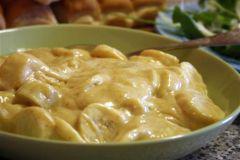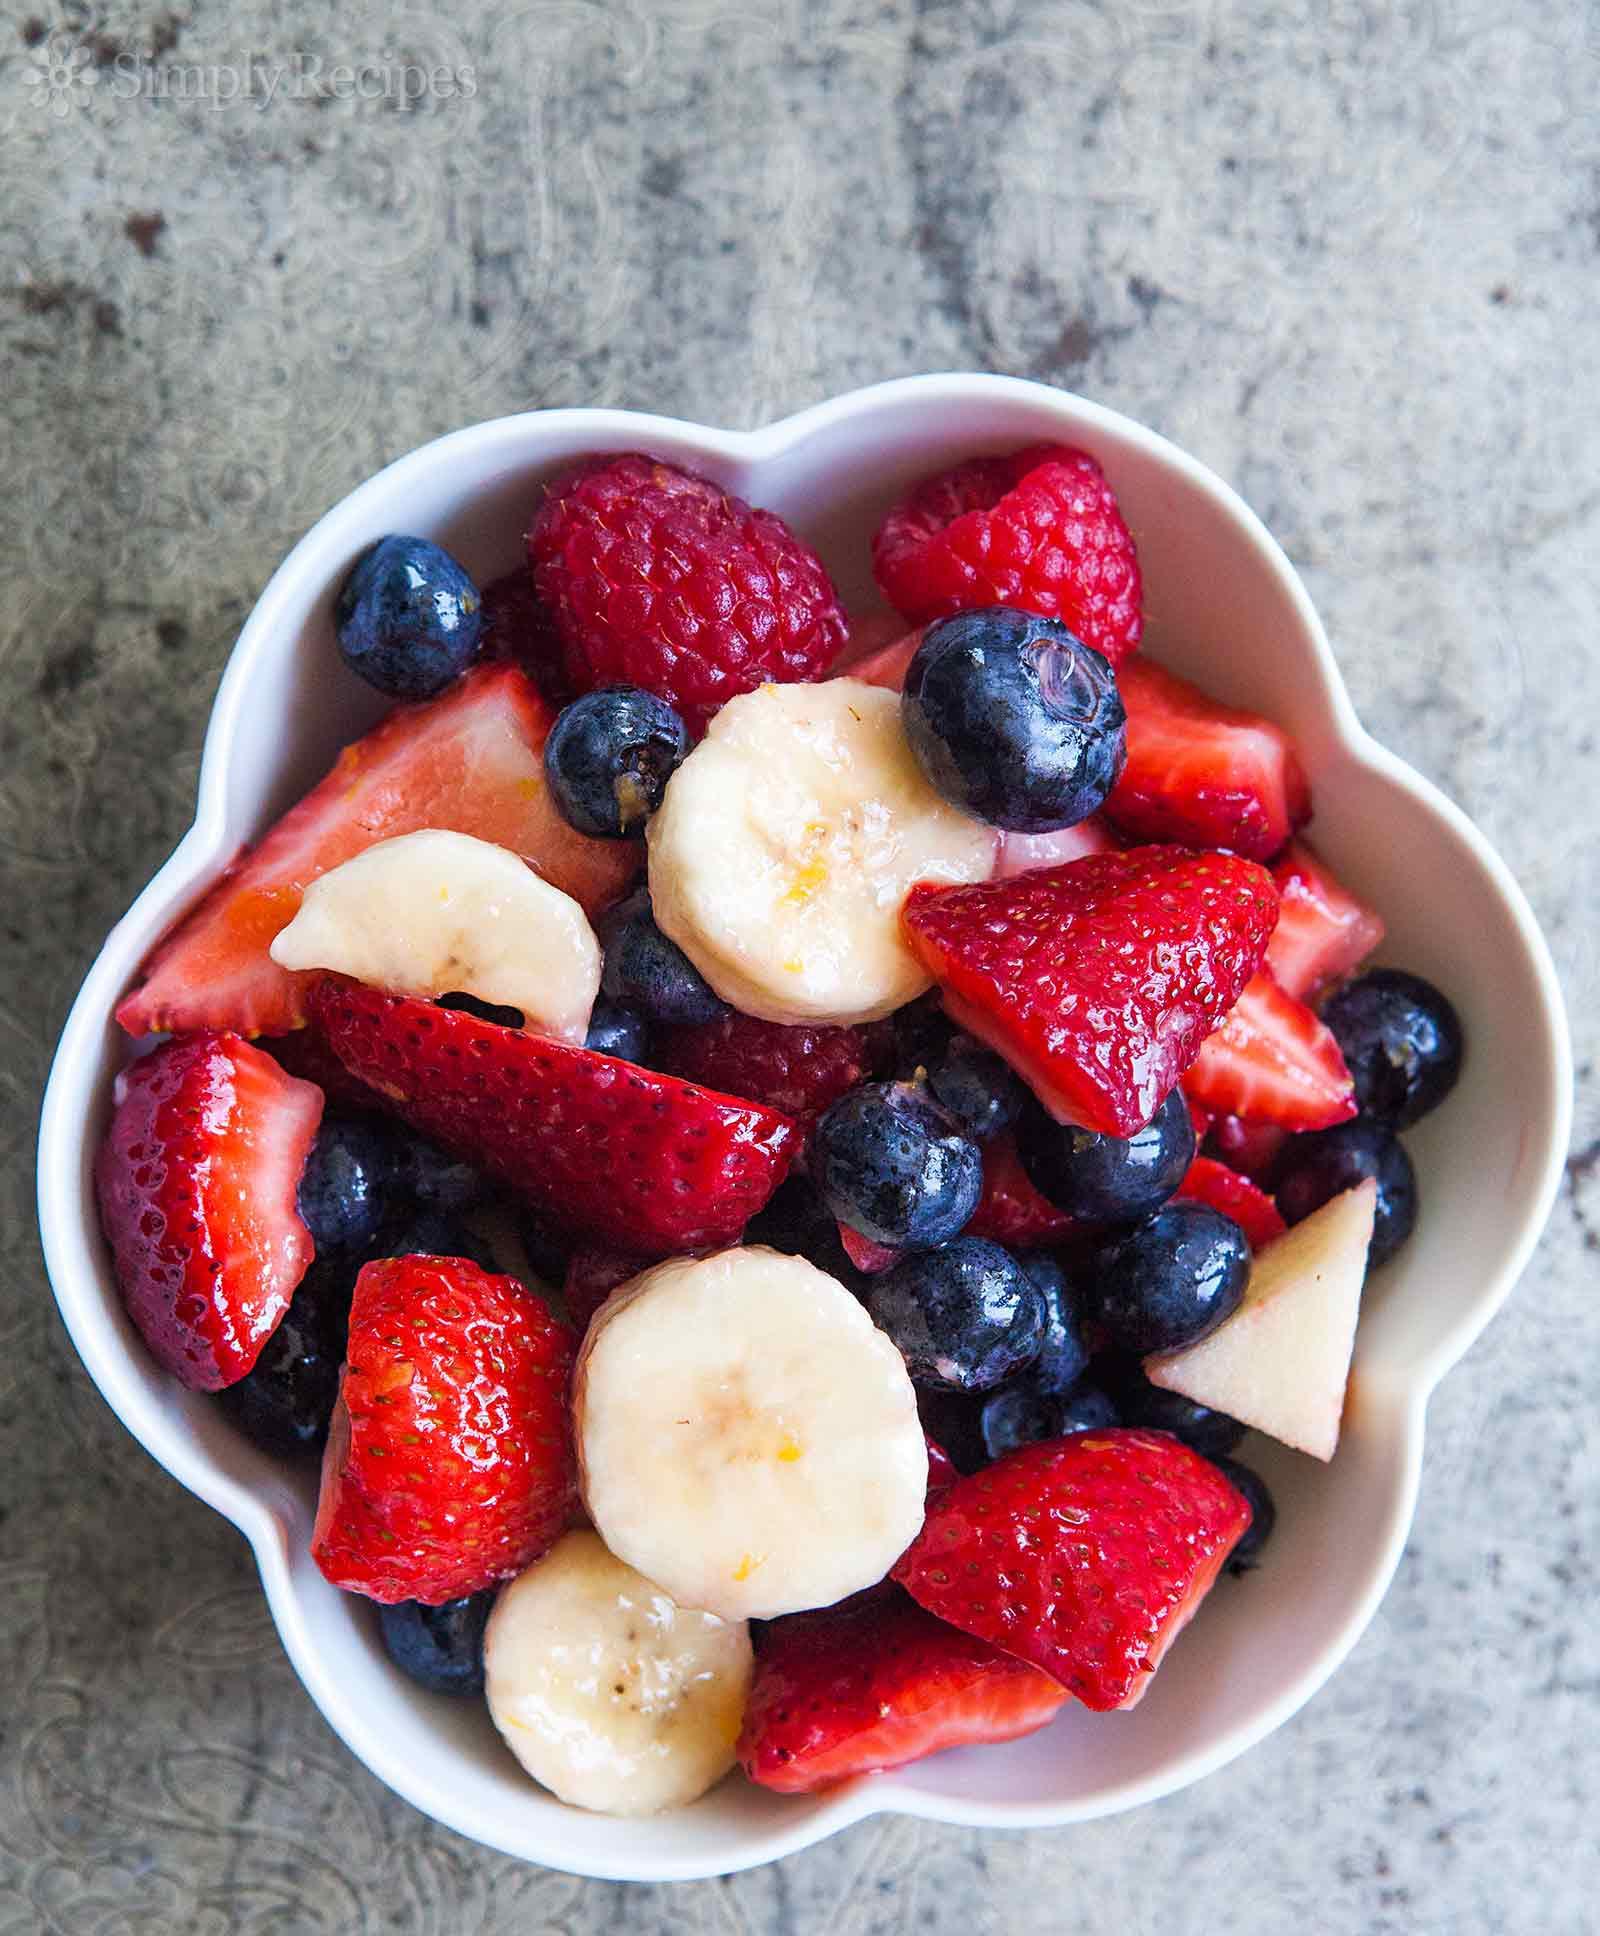The first image is the image on the left, the second image is the image on the right. Examine the images to the left and right. Is the description "The left image shows mixed fruit pieces in a white bowl, and the right image shows sliced bananas in an octagon-shaped black bowl." accurate? Answer yes or no. No. The first image is the image on the left, the second image is the image on the right. Analyze the images presented: Is the assertion "there is a white bowl with strawberries bananas and other varying fruits" valid? Answer yes or no. Yes. 